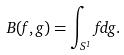<formula> <loc_0><loc_0><loc_500><loc_500>B ( f , g ) = \int _ { S ^ { 1 } } f d g .</formula> 